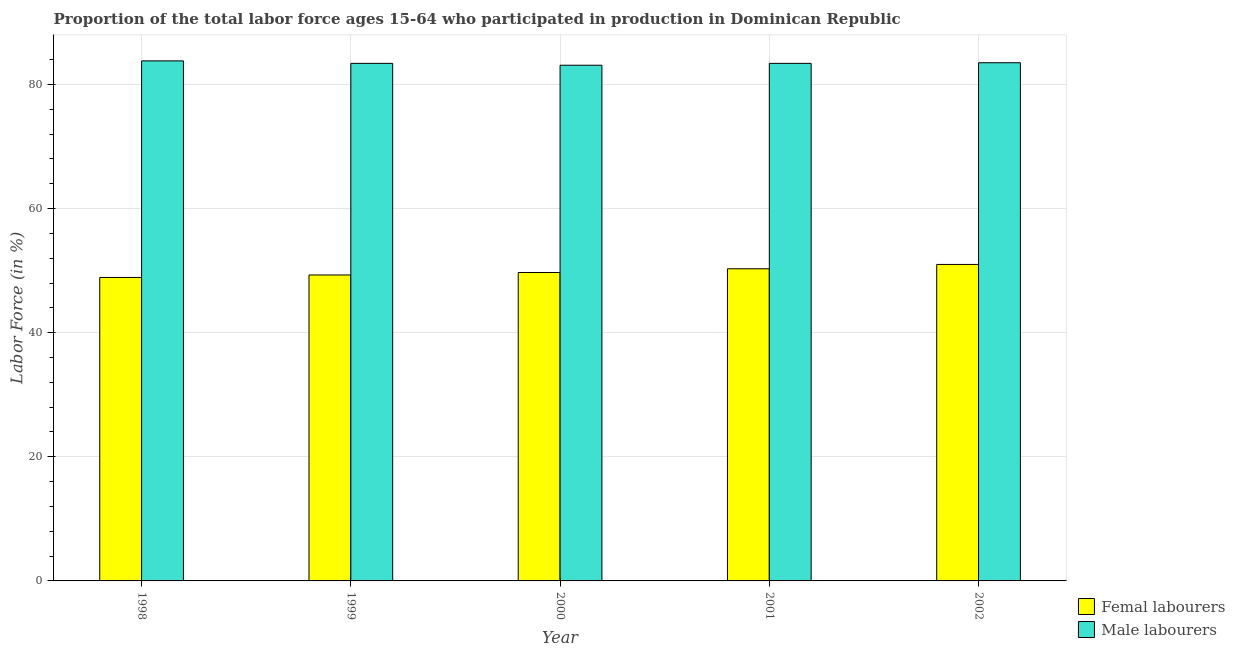Are the number of bars per tick equal to the number of legend labels?
Keep it short and to the point. Yes. Are the number of bars on each tick of the X-axis equal?
Provide a short and direct response. Yes. How many bars are there on the 3rd tick from the left?
Give a very brief answer. 2. What is the percentage of male labour force in 1999?
Ensure brevity in your answer.  83.4. Across all years, what is the maximum percentage of female labor force?
Your answer should be very brief. 51. Across all years, what is the minimum percentage of female labor force?
Make the answer very short. 48.9. In which year was the percentage of male labour force maximum?
Your answer should be compact. 1998. In which year was the percentage of male labour force minimum?
Make the answer very short. 2000. What is the total percentage of male labour force in the graph?
Keep it short and to the point. 417.2. What is the difference between the percentage of female labor force in 1998 and that in 2000?
Ensure brevity in your answer.  -0.8. What is the difference between the percentage of female labor force in 2000 and the percentage of male labour force in 2001?
Provide a succinct answer. -0.6. What is the average percentage of male labour force per year?
Provide a short and direct response. 83.44. In the year 1999, what is the difference between the percentage of male labour force and percentage of female labor force?
Keep it short and to the point. 0. What is the ratio of the percentage of male labour force in 1999 to that in 2000?
Your answer should be very brief. 1. Is the percentage of female labor force in 2001 less than that in 2002?
Make the answer very short. Yes. Is the difference between the percentage of female labor force in 1998 and 2002 greater than the difference between the percentage of male labour force in 1998 and 2002?
Keep it short and to the point. No. What is the difference between the highest and the second highest percentage of female labor force?
Ensure brevity in your answer.  0.7. What is the difference between the highest and the lowest percentage of female labor force?
Offer a very short reply. 2.1. Is the sum of the percentage of female labor force in 2001 and 2002 greater than the maximum percentage of male labour force across all years?
Your response must be concise. Yes. What does the 2nd bar from the left in 1999 represents?
Your answer should be very brief. Male labourers. What does the 1st bar from the right in 2001 represents?
Provide a succinct answer. Male labourers. Are all the bars in the graph horizontal?
Give a very brief answer. No. What is the difference between two consecutive major ticks on the Y-axis?
Provide a short and direct response. 20. Does the graph contain grids?
Make the answer very short. Yes. What is the title of the graph?
Ensure brevity in your answer.  Proportion of the total labor force ages 15-64 who participated in production in Dominican Republic. What is the label or title of the X-axis?
Provide a short and direct response. Year. What is the label or title of the Y-axis?
Ensure brevity in your answer.  Labor Force (in %). What is the Labor Force (in %) of Femal labourers in 1998?
Your answer should be very brief. 48.9. What is the Labor Force (in %) in Male labourers in 1998?
Give a very brief answer. 83.8. What is the Labor Force (in %) in Femal labourers in 1999?
Your answer should be compact. 49.3. What is the Labor Force (in %) of Male labourers in 1999?
Provide a succinct answer. 83.4. What is the Labor Force (in %) of Femal labourers in 2000?
Your response must be concise. 49.7. What is the Labor Force (in %) in Male labourers in 2000?
Your response must be concise. 83.1. What is the Labor Force (in %) of Femal labourers in 2001?
Provide a short and direct response. 50.3. What is the Labor Force (in %) of Male labourers in 2001?
Ensure brevity in your answer.  83.4. What is the Labor Force (in %) in Femal labourers in 2002?
Your response must be concise. 51. What is the Labor Force (in %) of Male labourers in 2002?
Offer a terse response. 83.5. Across all years, what is the maximum Labor Force (in %) in Femal labourers?
Offer a very short reply. 51. Across all years, what is the maximum Labor Force (in %) in Male labourers?
Provide a short and direct response. 83.8. Across all years, what is the minimum Labor Force (in %) in Femal labourers?
Provide a short and direct response. 48.9. Across all years, what is the minimum Labor Force (in %) of Male labourers?
Keep it short and to the point. 83.1. What is the total Labor Force (in %) of Femal labourers in the graph?
Offer a very short reply. 249.2. What is the total Labor Force (in %) of Male labourers in the graph?
Your answer should be compact. 417.2. What is the difference between the Labor Force (in %) in Male labourers in 1998 and that in 1999?
Make the answer very short. 0.4. What is the difference between the Labor Force (in %) in Male labourers in 1998 and that in 2001?
Your answer should be compact. 0.4. What is the difference between the Labor Force (in %) in Femal labourers in 1999 and that in 2000?
Your answer should be compact. -0.4. What is the difference between the Labor Force (in %) in Male labourers in 1999 and that in 2000?
Provide a short and direct response. 0.3. What is the difference between the Labor Force (in %) of Male labourers in 1999 and that in 2001?
Offer a terse response. 0. What is the difference between the Labor Force (in %) of Male labourers in 2000 and that in 2002?
Your response must be concise. -0.4. What is the difference between the Labor Force (in %) of Femal labourers in 1998 and the Labor Force (in %) of Male labourers in 1999?
Your answer should be compact. -34.5. What is the difference between the Labor Force (in %) in Femal labourers in 1998 and the Labor Force (in %) in Male labourers in 2000?
Offer a terse response. -34.2. What is the difference between the Labor Force (in %) in Femal labourers in 1998 and the Labor Force (in %) in Male labourers in 2001?
Provide a short and direct response. -34.5. What is the difference between the Labor Force (in %) of Femal labourers in 1998 and the Labor Force (in %) of Male labourers in 2002?
Offer a very short reply. -34.6. What is the difference between the Labor Force (in %) in Femal labourers in 1999 and the Labor Force (in %) in Male labourers in 2000?
Offer a terse response. -33.8. What is the difference between the Labor Force (in %) of Femal labourers in 1999 and the Labor Force (in %) of Male labourers in 2001?
Keep it short and to the point. -34.1. What is the difference between the Labor Force (in %) in Femal labourers in 1999 and the Labor Force (in %) in Male labourers in 2002?
Make the answer very short. -34.2. What is the difference between the Labor Force (in %) of Femal labourers in 2000 and the Labor Force (in %) of Male labourers in 2001?
Give a very brief answer. -33.7. What is the difference between the Labor Force (in %) of Femal labourers in 2000 and the Labor Force (in %) of Male labourers in 2002?
Provide a succinct answer. -33.8. What is the difference between the Labor Force (in %) in Femal labourers in 2001 and the Labor Force (in %) in Male labourers in 2002?
Provide a succinct answer. -33.2. What is the average Labor Force (in %) in Femal labourers per year?
Your answer should be very brief. 49.84. What is the average Labor Force (in %) in Male labourers per year?
Provide a short and direct response. 83.44. In the year 1998, what is the difference between the Labor Force (in %) in Femal labourers and Labor Force (in %) in Male labourers?
Your answer should be compact. -34.9. In the year 1999, what is the difference between the Labor Force (in %) in Femal labourers and Labor Force (in %) in Male labourers?
Give a very brief answer. -34.1. In the year 2000, what is the difference between the Labor Force (in %) in Femal labourers and Labor Force (in %) in Male labourers?
Offer a terse response. -33.4. In the year 2001, what is the difference between the Labor Force (in %) of Femal labourers and Labor Force (in %) of Male labourers?
Ensure brevity in your answer.  -33.1. In the year 2002, what is the difference between the Labor Force (in %) of Femal labourers and Labor Force (in %) of Male labourers?
Your answer should be very brief. -32.5. What is the ratio of the Labor Force (in %) in Femal labourers in 1998 to that in 1999?
Your response must be concise. 0.99. What is the ratio of the Labor Force (in %) of Femal labourers in 1998 to that in 2000?
Offer a terse response. 0.98. What is the ratio of the Labor Force (in %) of Male labourers in 1998 to that in 2000?
Your response must be concise. 1.01. What is the ratio of the Labor Force (in %) of Femal labourers in 1998 to that in 2001?
Your answer should be very brief. 0.97. What is the ratio of the Labor Force (in %) in Male labourers in 1998 to that in 2001?
Offer a very short reply. 1. What is the ratio of the Labor Force (in %) in Femal labourers in 1998 to that in 2002?
Make the answer very short. 0.96. What is the ratio of the Labor Force (in %) of Male labourers in 1998 to that in 2002?
Ensure brevity in your answer.  1. What is the ratio of the Labor Force (in %) in Femal labourers in 1999 to that in 2000?
Provide a short and direct response. 0.99. What is the ratio of the Labor Force (in %) of Femal labourers in 1999 to that in 2001?
Provide a succinct answer. 0.98. What is the ratio of the Labor Force (in %) in Male labourers in 1999 to that in 2001?
Your answer should be compact. 1. What is the ratio of the Labor Force (in %) of Femal labourers in 1999 to that in 2002?
Keep it short and to the point. 0.97. What is the ratio of the Labor Force (in %) of Male labourers in 1999 to that in 2002?
Offer a terse response. 1. What is the ratio of the Labor Force (in %) of Femal labourers in 2000 to that in 2001?
Offer a terse response. 0.99. What is the ratio of the Labor Force (in %) of Femal labourers in 2000 to that in 2002?
Provide a succinct answer. 0.97. What is the ratio of the Labor Force (in %) in Femal labourers in 2001 to that in 2002?
Provide a succinct answer. 0.99. What is the difference between the highest and the second highest Labor Force (in %) in Femal labourers?
Make the answer very short. 0.7. What is the difference between the highest and the second highest Labor Force (in %) of Male labourers?
Offer a very short reply. 0.3. What is the difference between the highest and the lowest Labor Force (in %) in Femal labourers?
Offer a terse response. 2.1. What is the difference between the highest and the lowest Labor Force (in %) in Male labourers?
Make the answer very short. 0.7. 